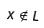Convert formula to latex. <formula><loc_0><loc_0><loc_500><loc_500>x \notin L</formula> 